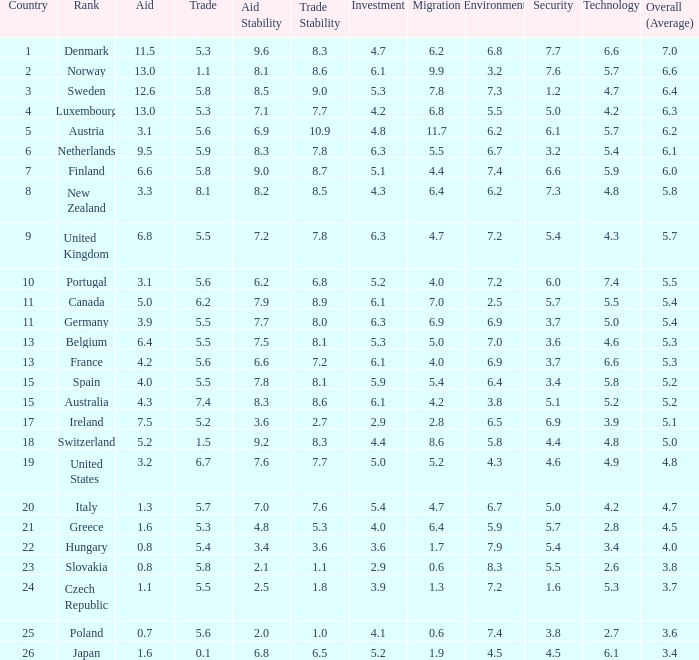What is the migration rating when trade is 5.7? 4.7. Help me parse the entirety of this table. {'header': ['Country', 'Rank', 'Aid', 'Trade', 'Aid Stability', 'Trade Stability', 'Investment', 'Migration', 'Environment', 'Security', 'Technology', 'Overall (Average)'], 'rows': [['1', 'Denmark', '11.5', '5.3', '9.6', '8.3', '4.7', '6.2', '6.8', '7.7', '6.6', '7.0'], ['2', 'Norway', '13.0', '1.1', '8.1', '8.6', '6.1', '9.9', '3.2', '7.6', '5.7', '6.6'], ['3', 'Sweden', '12.6', '5.8', '8.5', '9.0', '5.3', '7.8', '7.3', '1.2', '4.7', '6.4'], ['4', 'Luxembourg', '13.0', '5.3', '7.1', '7.7', '4.2', '6.8', '5.5', '5.0', '4.2', '6.3'], ['5', 'Austria', '3.1', '5.6', '6.9', '10.9', '4.8', '11.7', '6.2', '6.1', '5.7', '6.2'], ['6', 'Netherlands', '9.5', '5.9', '8.3', '7.8', '6.3', '5.5', '6.7', '3.2', '5.4', '6.1'], ['7', 'Finland', '6.6', '5.8', '9.0', '8.7', '5.1', '4.4', '7.4', '6.6', '5.9', '6.0'], ['8', 'New Zealand', '3.3', '8.1', '8.2', '8.5', '4.3', '6.4', '6.2', '7.3', '4.8', '5.8'], ['9', 'United Kingdom', '6.8', '5.5', '7.2', '7.8', '6.3', '4.7', '7.2', '5.4', '4.3', '5.7'], ['10', 'Portugal', '3.1', '5.6', '6.2', '6.8', '5.2', '4.0', '7.2', '6.0', '7.4', '5.5'], ['11', 'Canada', '5.0', '6.2', '7.9', '8.9', '6.1', '7.0', '2.5', '5.7', '5.5', '5.4'], ['11', 'Germany', '3.9', '5.5', '7.7', '8.0', '6.3', '6.9', '6.9', '3.7', '5.0', '5.4'], ['13', 'Belgium', '6.4', '5.5', '7.5', '8.1', '5.3', '5.0', '7.0', '3.6', '4.6', '5.3'], ['13', 'France', '4.2', '5.6', '6.6', '7.2', '6.1', '4.0', '6.9', '3.7', '6.6', '5.3'], ['15', 'Spain', '4.0', '5.5', '7.8', '8.1', '5.9', '5.4', '6.4', '3.4', '5.8', '5.2'], ['15', 'Australia', '4.3', '7.4', '8.3', '8.6', '6.1', '4.2', '3.8', '5.1', '5.2', '5.2'], ['17', 'Ireland', '7.5', '5.2', '3.6', '2.7', '2.9', '2.8', '6.5', '6.9', '3.9', '5.1'], ['18', 'Switzerland', '5.2', '1.5', '9.2', '8.3', '4.4', '8.6', '5.8', '4.4', '4.8', '5.0'], ['19', 'United States', '3.2', '6.7', '7.6', '7.7', '5.0', '5.2', '4.3', '4.6', '4.9', '4.8'], ['20', 'Italy', '1.3', '5.7', '7.0', '7.6', '5.4', '4.7', '6.7', '5.0', '4.2', '4.7'], ['21', 'Greece', '1.6', '5.3', '4.8', '5.3', '4.0', '6.4', '5.9', '5.7', '2.8', '4.5'], ['22', 'Hungary', '0.8', '5.4', '3.4', '3.6', '3.6', '1.7', '7.9', '5.4', '3.4', '4.0'], ['23', 'Slovakia', '0.8', '5.8', '2.1', '1.1', '2.9', '0.6', '8.3', '5.5', '2.6', '3.8'], ['24', 'Czech Republic', '1.1', '5.5', '2.5', '1.8', '3.9', '1.3', '7.2', '1.6', '5.3', '3.7'], ['25', 'Poland', '0.7', '5.6', '2.0', '1.0', '4.1', '0.6', '7.4', '3.8', '2.7', '3.6'], ['26', 'Japan', '1.6', '0.1', '6.8', '6.5', '5.2', '1.9', '4.5', '4.5', '6.1', '3.4']]} 